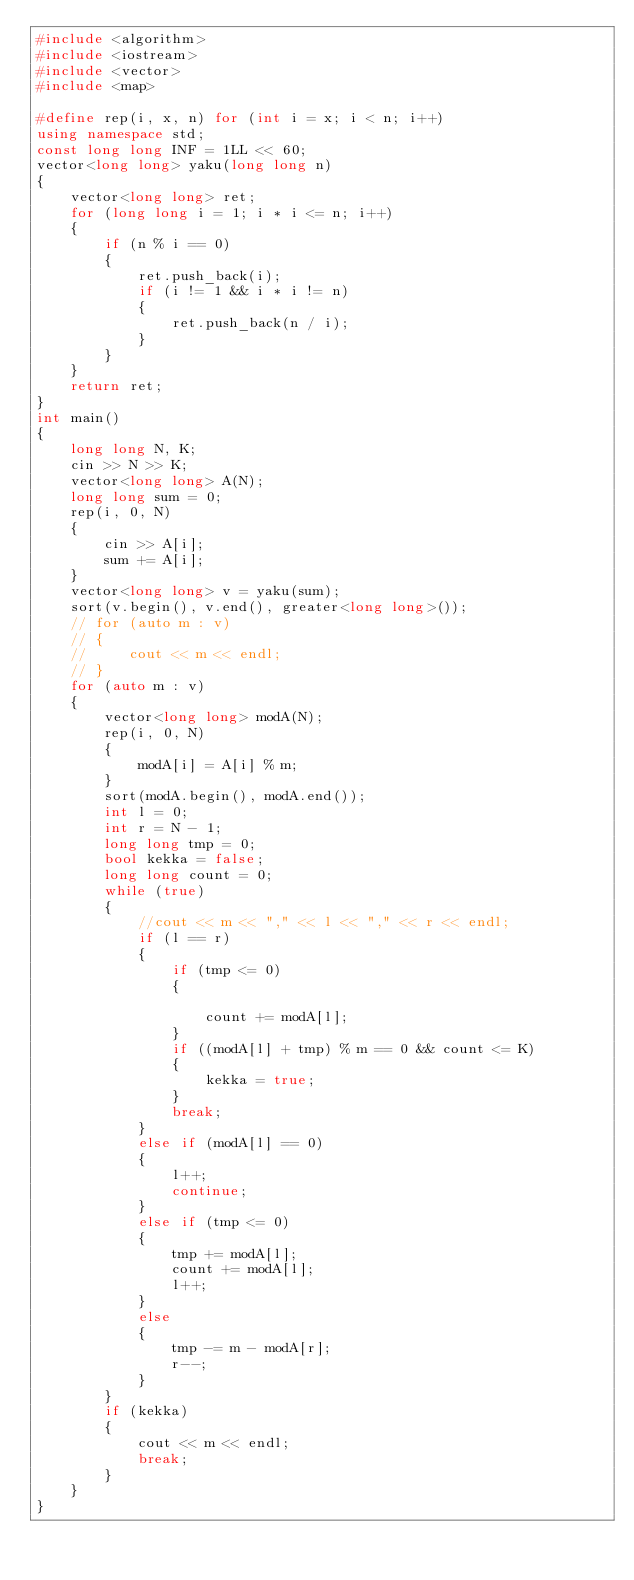<code> <loc_0><loc_0><loc_500><loc_500><_C++_>#include <algorithm>
#include <iostream>
#include <vector>
#include <map>

#define rep(i, x, n) for (int i = x; i < n; i++)
using namespace std;
const long long INF = 1LL << 60;
vector<long long> yaku(long long n)
{
    vector<long long> ret;
    for (long long i = 1; i * i <= n; i++)
    {
        if (n % i == 0)
        {
            ret.push_back(i);
            if (i != 1 && i * i != n)
            {
                ret.push_back(n / i);
            }
        }
    }
    return ret;
}
int main()
{
    long long N, K;
    cin >> N >> K;
    vector<long long> A(N);
    long long sum = 0;
    rep(i, 0, N)
    {
        cin >> A[i];
        sum += A[i];
    }
    vector<long long> v = yaku(sum);
    sort(v.begin(), v.end(), greater<long long>());
    // for (auto m : v)
    // {
    //     cout << m << endl;
    // }
    for (auto m : v)
    {
        vector<long long> modA(N);
        rep(i, 0, N)
        {
            modA[i] = A[i] % m;
        }
        sort(modA.begin(), modA.end());
        int l = 0;
        int r = N - 1;
        long long tmp = 0;
        bool kekka = false;
        long long count = 0;
        while (true)
        {
            //cout << m << "," << l << "," << r << endl;
            if (l == r)
            {
                if (tmp <= 0)
                {

                    count += modA[l];
                }
                if ((modA[l] + tmp) % m == 0 && count <= K)
                {
                    kekka = true;
                }
                break;
            }
            else if (modA[l] == 0)
            {
                l++;
                continue;
            }
            else if (tmp <= 0)
            {
                tmp += modA[l];
                count += modA[l];
                l++;
            }
            else
            {
                tmp -= m - modA[r];
                r--;
            }
        }
        if (kekka)
        {
            cout << m << endl;
            break;
        }
    }
}</code> 